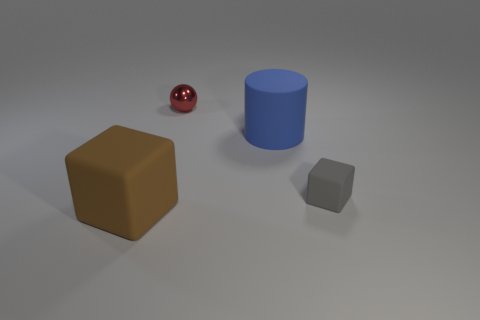Do the sphere and the rubber block on the left side of the large matte cylinder have the same color?
Ensure brevity in your answer.  No. What color is the matte object that is on the right side of the small metal thing and in front of the large matte cylinder?
Keep it short and to the point. Gray. There is a matte block on the right side of the big brown cube; what number of objects are in front of it?
Give a very brief answer. 1. Is there a tiny red metal thing of the same shape as the small gray thing?
Your answer should be compact. No. There is a large thing on the right side of the big brown cube; does it have the same shape as the big thing that is in front of the gray object?
Make the answer very short. No. What number of objects are tiny gray rubber things or brown rubber blocks?
Offer a terse response. 2. There is another thing that is the same shape as the gray thing; what size is it?
Offer a very short reply. Large. Are there more red metal objects that are to the left of the blue cylinder than purple rubber cubes?
Your answer should be very brief. Yes. Does the cylinder have the same material as the red sphere?
Your answer should be very brief. No. How many things are big objects that are in front of the large blue matte thing or matte objects that are on the left side of the large cylinder?
Offer a very short reply. 1. 